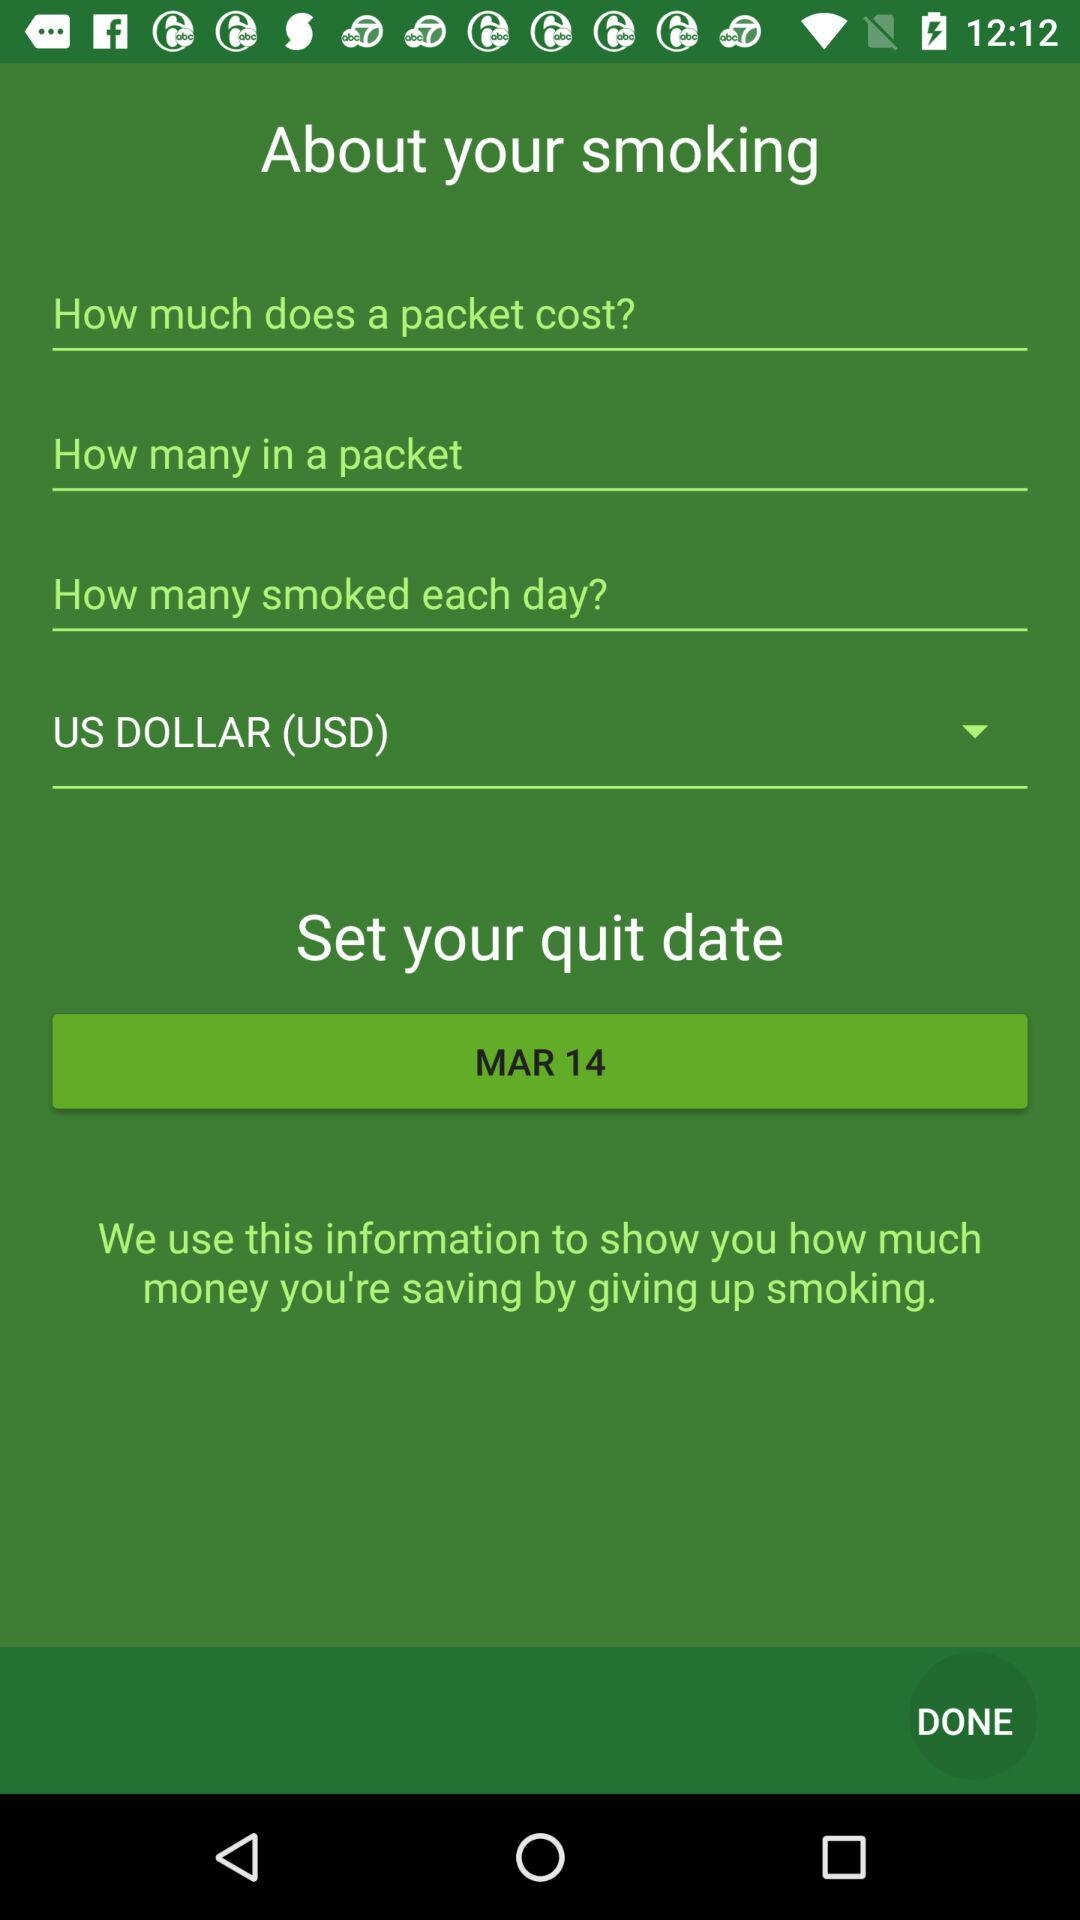Which currency is selected? The selected currency is the US dollar (USD). 